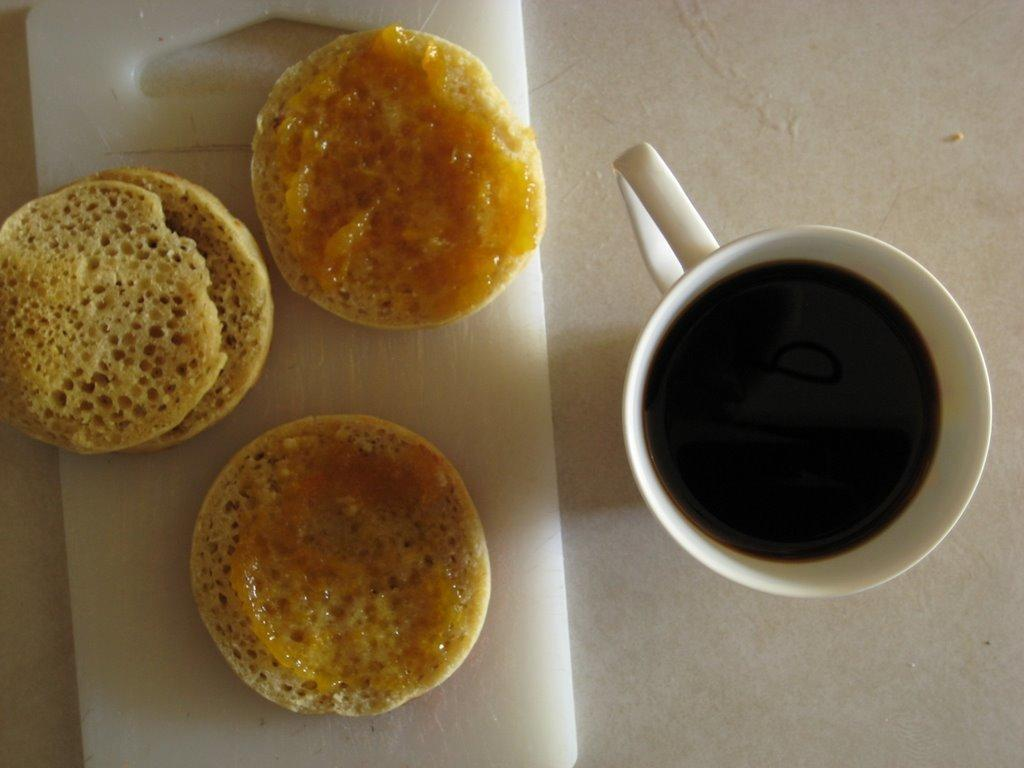What is on the chopping board in the image? There is food on a chopping board in the image. What type of beverage is in the cup on the table? There is a cup of tea on a table in the image. What color is the table in the image? The table is white in color. Where is the hook for hanging underwear in the image? There is no hook for hanging underwear present in the image. What type of yoke is used to carry items in the image? There is no yoke present in the image. 